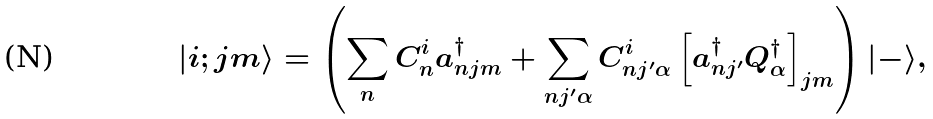<formula> <loc_0><loc_0><loc_500><loc_500>| i ; j m \rangle = \left ( \sum _ { n } C ^ { i } _ { n } a ^ { \dagger } _ { n j m } + \sum _ { n j ^ { \prime } \alpha } C ^ { i } _ { n j ^ { \prime } \alpha } \left [ a ^ { \dagger } _ { n j ^ { \prime } } Q ^ { \dagger } _ { \alpha } \right ] _ { j m } \right ) | - \rangle ,</formula> 